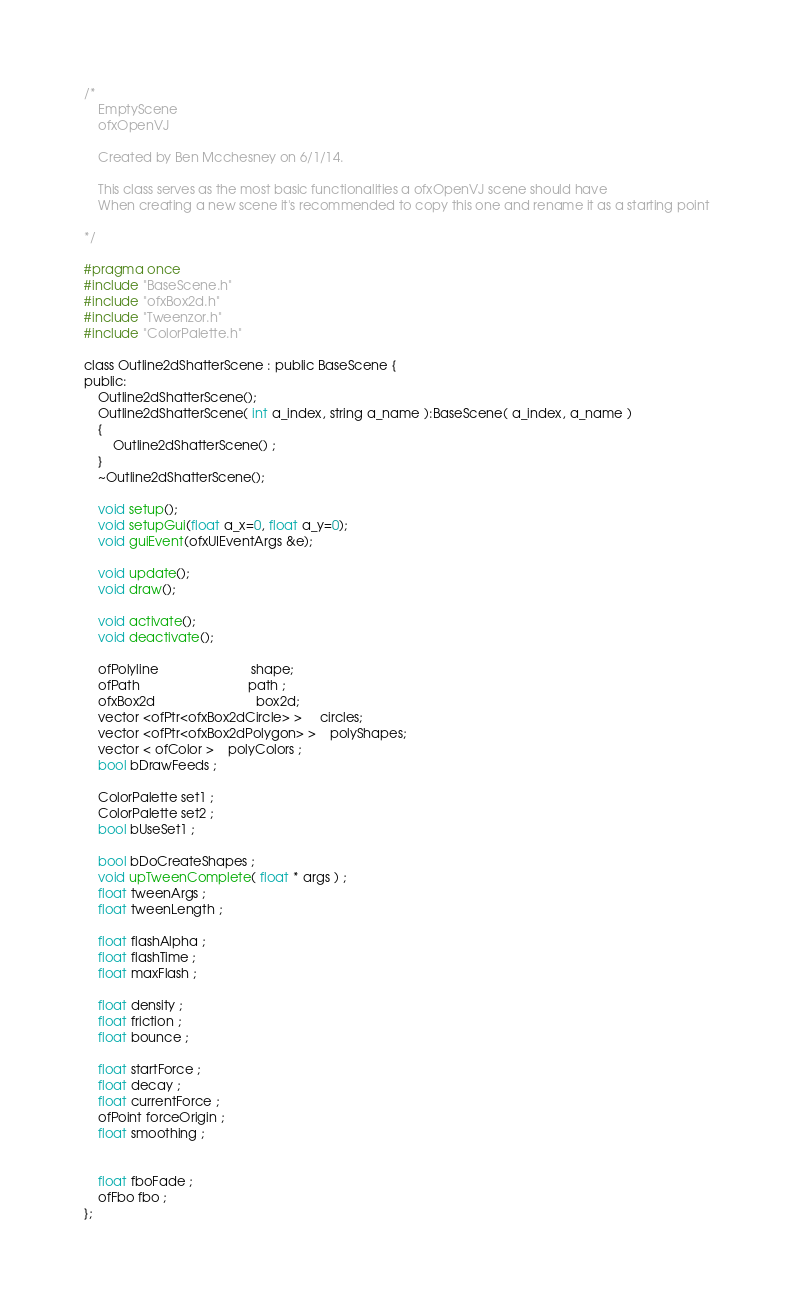<code> <loc_0><loc_0><loc_500><loc_500><_C_>/*
    EmptyScene
    ofxOpenVJ
 
    Created by Ben Mcchesney on 6/1/14.
 
    This class serves as the most basic functionalities a ofxOpenVJ scene should have
    When creating a new scene it's recommended to copy this one and rename it as a starting point
 
*/

#pragma once 
#include "BaseScene.h"
#include "ofxBox2d.h"
#include "Tweenzor.h"
#include "ColorPalette.h"

class Outline2dShatterScene : public BaseScene {
public:
    Outline2dShatterScene();
    Outline2dShatterScene( int a_index, string a_name ):BaseScene( a_index, a_name )
    {
        Outline2dShatterScene() ;
    }
    ~Outline2dShatterScene();
    
    void setup();
    void setupGui(float a_x=0, float a_y=0);
    void guiEvent(ofxUIEventArgs &e);
    
    void update();
    void draw();
    
    void activate();
    void deactivate();

    ofPolyline                          shape;
    ofPath                              path ;
	ofxBox2d                            box2d;
	vector <ofPtr<ofxBox2dCircle> >     circles;
	vector <ofPtr<ofxBox2dPolygon> >	polyShapes;
    vector < ofColor >	polyColors ;
    bool bDrawFeeds ;
    
    ColorPalette set1 ;
    ColorPalette set2 ;
    bool bUseSet1 ;

    bool bDoCreateShapes ;
    void upTweenComplete( float * args ) ;
    float tweenArgs ;
    float tweenLength ;
    
    float flashAlpha ;
    float flashTime ;
    float maxFlash ;
    
    float density ;
    float friction ;
    float bounce ;
    
    float startForce ;
    float decay ;
    float currentForce ;
    ofPoint forceOrigin ;
    float smoothing ;
    
    
    float fboFade ;
    ofFbo fbo ;
};
</code> 